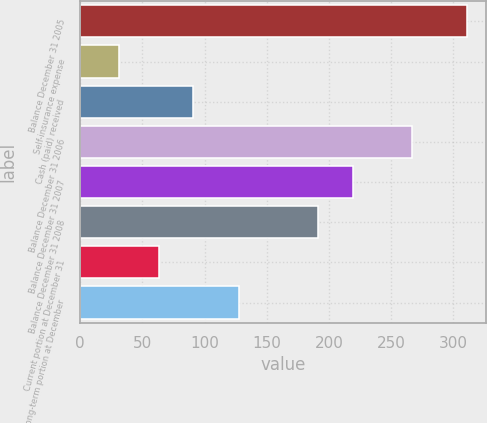Convert chart. <chart><loc_0><loc_0><loc_500><loc_500><bar_chart><fcel>Balance December 31 2005<fcel>Self-insurance expense<fcel>Cash (paid) received<fcel>Balance December 31 2006<fcel>Balance December 31 2007<fcel>Balance December 31 2008<fcel>Current portion at December 31<fcel>Long-term portion at December<nl><fcel>311<fcel>31<fcel>91<fcel>267<fcel>219<fcel>191<fcel>63<fcel>128<nl></chart> 